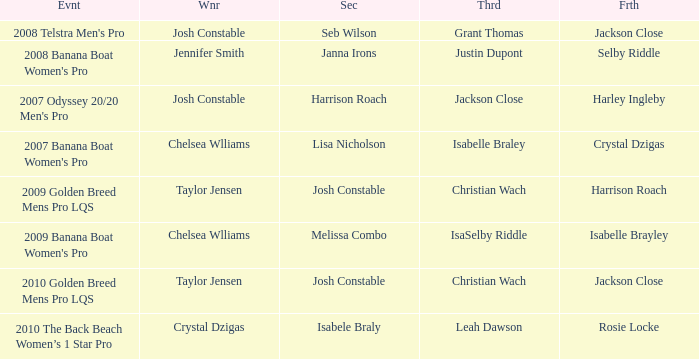Who was in Second Place with Isabelle Brayley came in Fourth? Melissa Combo. 